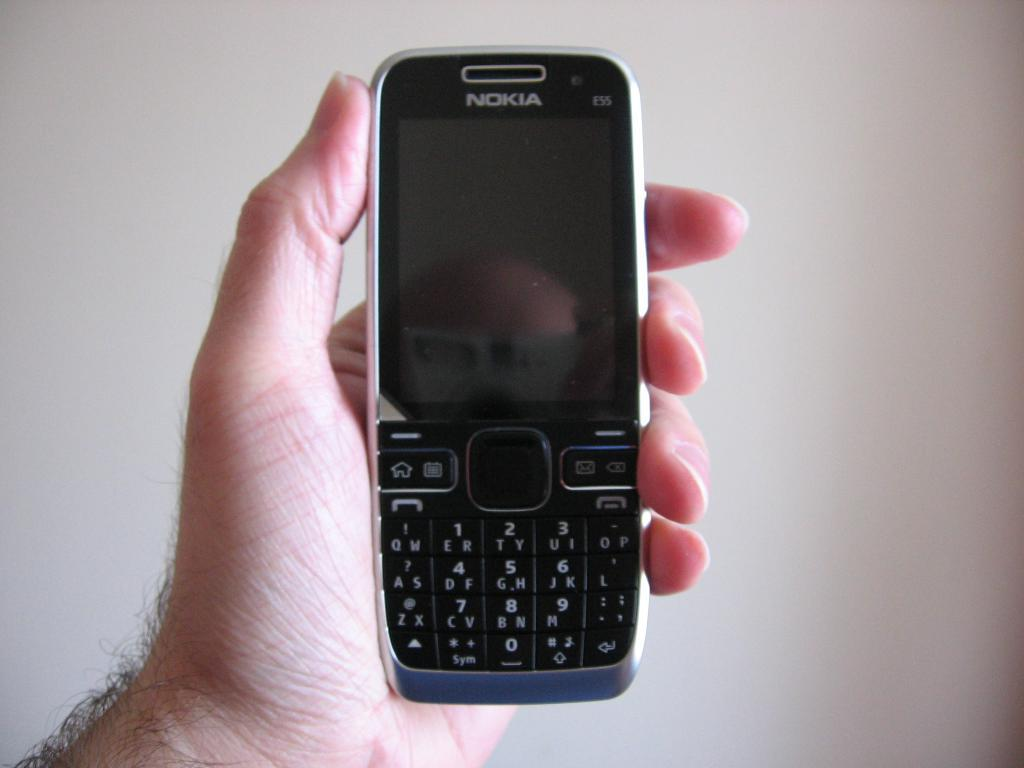<image>
Give a short and clear explanation of the subsequent image. Nokia phone is being held in somebody hand 